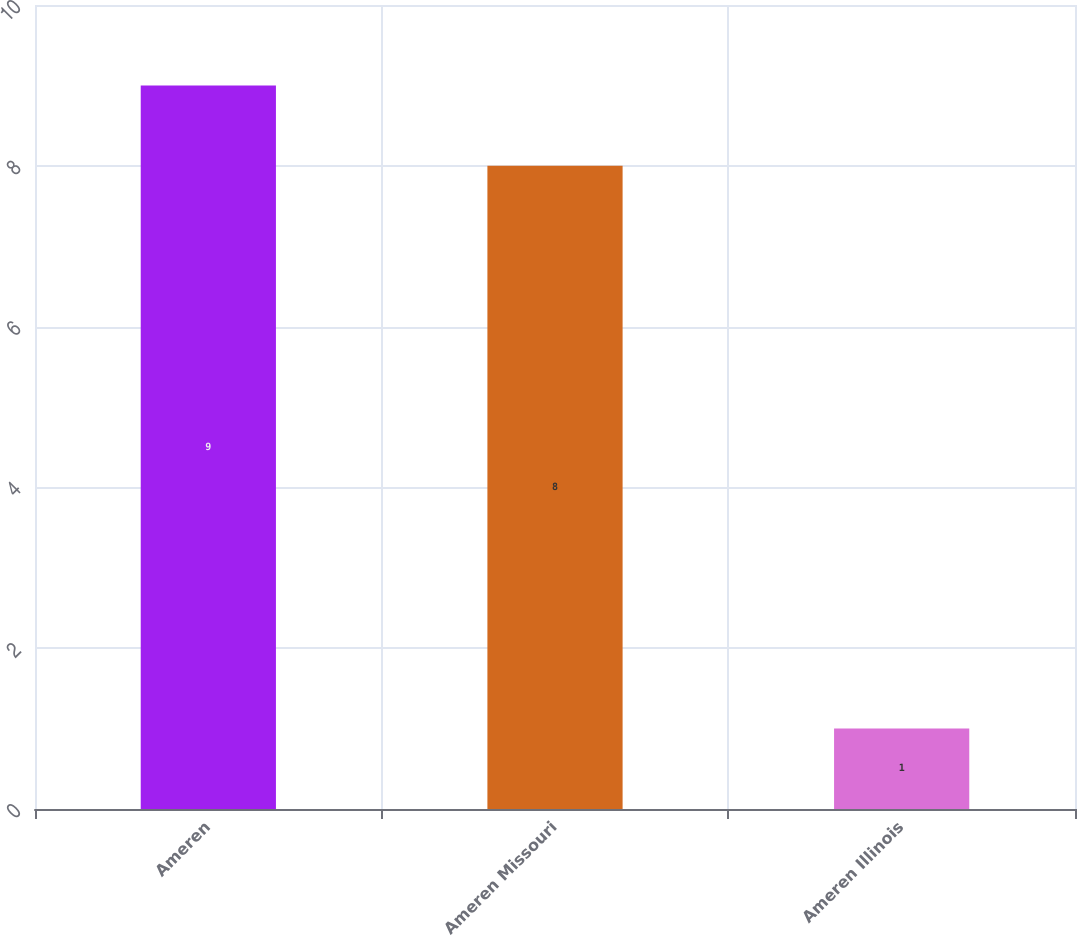Convert chart. <chart><loc_0><loc_0><loc_500><loc_500><bar_chart><fcel>Ameren<fcel>Ameren Missouri<fcel>Ameren Illinois<nl><fcel>9<fcel>8<fcel>1<nl></chart> 